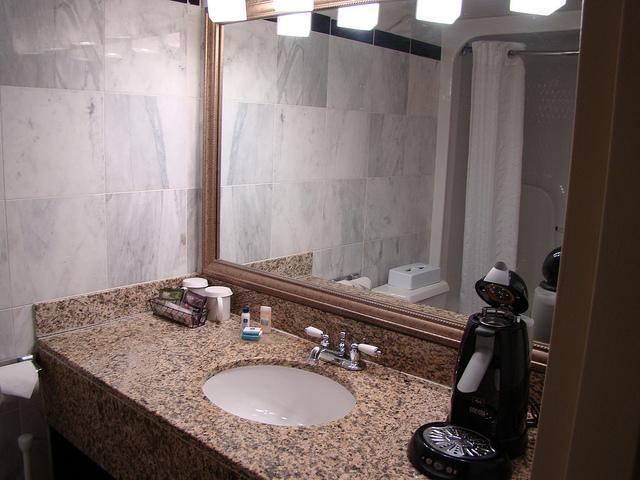Who folded the toilet paper roll into a point to the left of the sink?
Pick the right solution, then justify: 'Answer: answer
Rationale: rationale.'
Options: Nanny, clerk, cleaning staff, butler. Answer: cleaning staff.
Rationale: In most hotels, small touches seem welcoming to guests, including the folding of toilet paper into a point by housekeeping. 